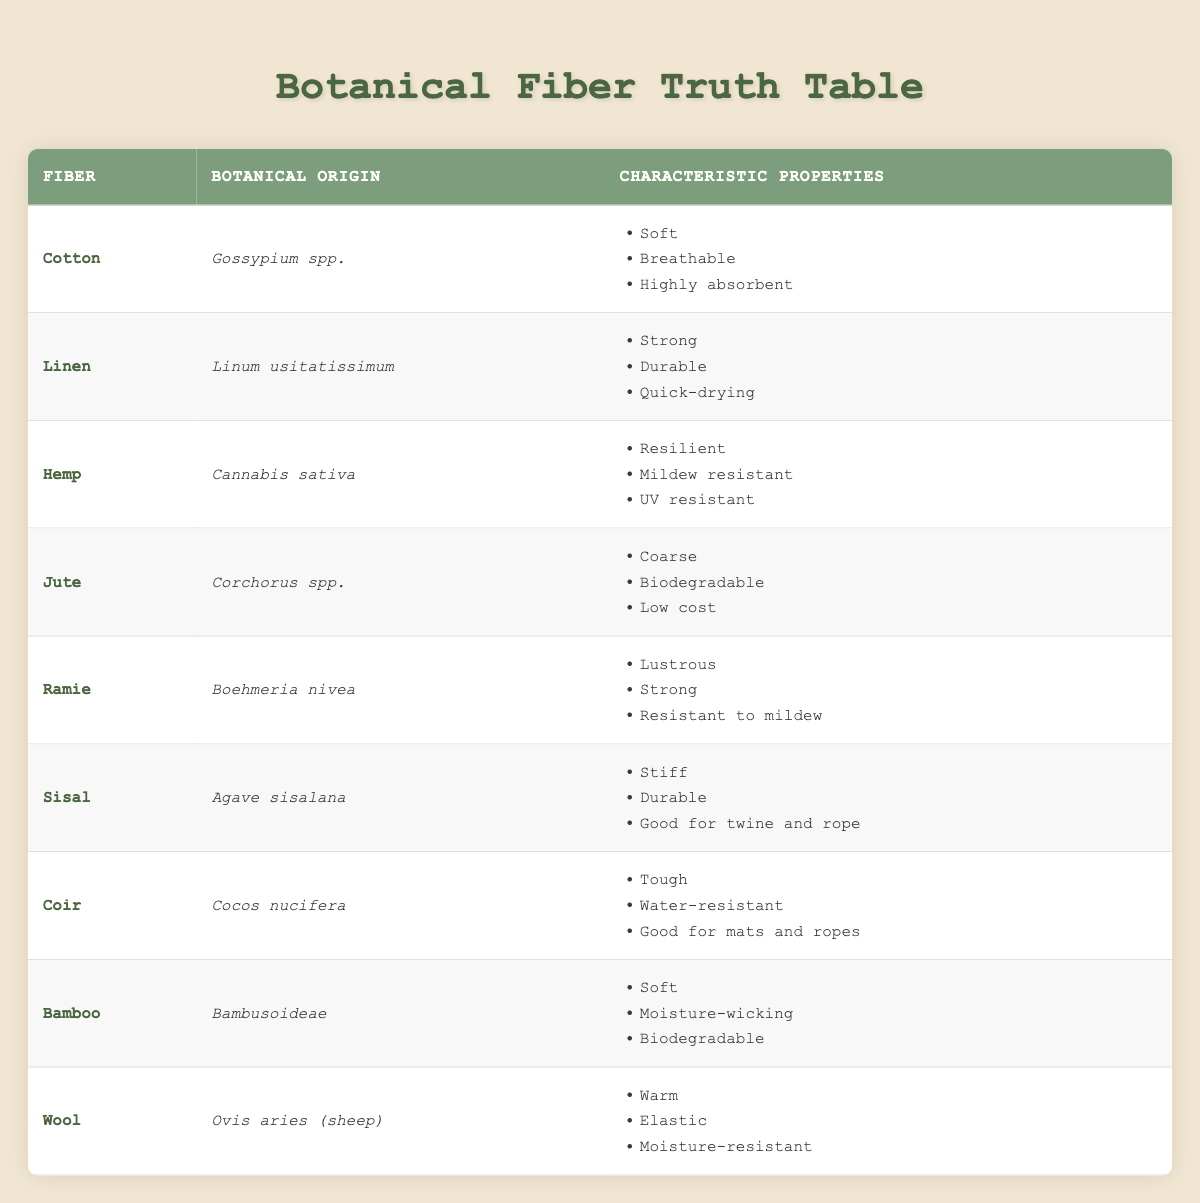What is the botanical origin of Linen? In the table, under the "Fiber" column, Linen is listed, and in the corresponding "Botanical Origin" column, it states "Linum usitatissimum."
Answer: Linum usitatissimum Which fiber type is characterized as "Coarse"? By scanning the "Characteristic Properties" column for each fiber, Jute is the only one that has "Coarse" listed among its properties.
Answer: Jute Is Bamboo biodegradable? The table lists "Biodegradable" as one of the characteristic properties of Bamboo, confirming that it is indeed biodegradable.
Answer: Yes Which fiber has the unique property of being "Mildew resistant"? By checking the "Characteristic Properties" column, both Hemp and Ramie are noted to be "Mildew resistant," leading to the conclusion that there are two such fibers.
Answer: Hemp and Ramie What is the average number of characteristic properties listed for the fibers in the table? Considering there are nine fiber types and each has three properties listed, the sum is 9 types * 3 properties = 27. The average is therefore 27/9 = 3.
Answer: 3 Which fiber has the most properties related to durability? Upon examining the fibers, Sisal and Linen are two fibers noted for their durability with associated properties that emphasize this quality. Sisal is “Durable” for its use in twine and rope, while Linen is listed as "Strong" and "Durable." Hence, both are noted for durability.
Answer: Sisal and Linen Is it true that all fibers listed in the table are derived from plants? The fibers mentioned in the table, such as Cotton, Linen, and Jute, all originate from plant species as indicated in their botanical origins. Therefore, this statement holds true.
Answer: Yes How many fibers in the table are derived from flowers? Within the given fiber types, Cotton and Jute are derived from flowering plants. Thus, two fibers can be classified as being from flowers.
Answer: 2 What properties do both Wool and Coir share? Reviewing the properties listed for both fibers, it is found that while Wool is "Warm," "Elastic," and "Moisture-resistant," Coir does not share any of these properties, indicating no common traits exist between them.
Answer: None 